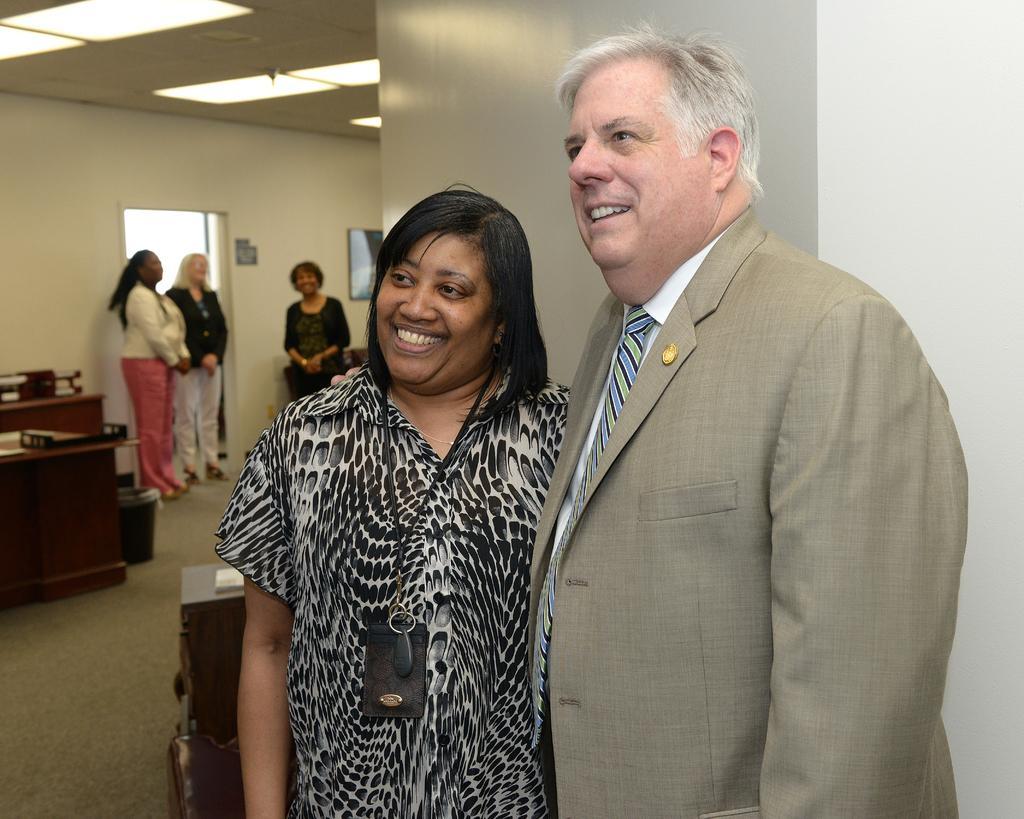How would you summarize this image in a sentence or two? In this image there is a man and a woman standing with a smile on their face, behind them there are three other women standing with a smile on their face, beside them there are tables and a trash can on the floor. 